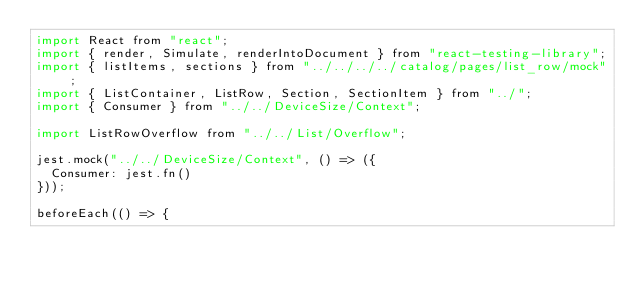Convert code to text. <code><loc_0><loc_0><loc_500><loc_500><_JavaScript_>import React from "react";
import { render, Simulate, renderIntoDocument } from "react-testing-library";
import { listItems, sections } from "../../../../catalog/pages/list_row/mock";
import { ListContainer, ListRow, Section, SectionItem } from "../";
import { Consumer } from "../../DeviceSize/Context";

import ListRowOverflow from "../../List/Overflow";

jest.mock("../../DeviceSize/Context", () => ({
  Consumer: jest.fn()
}));

beforeEach(() => {</code> 